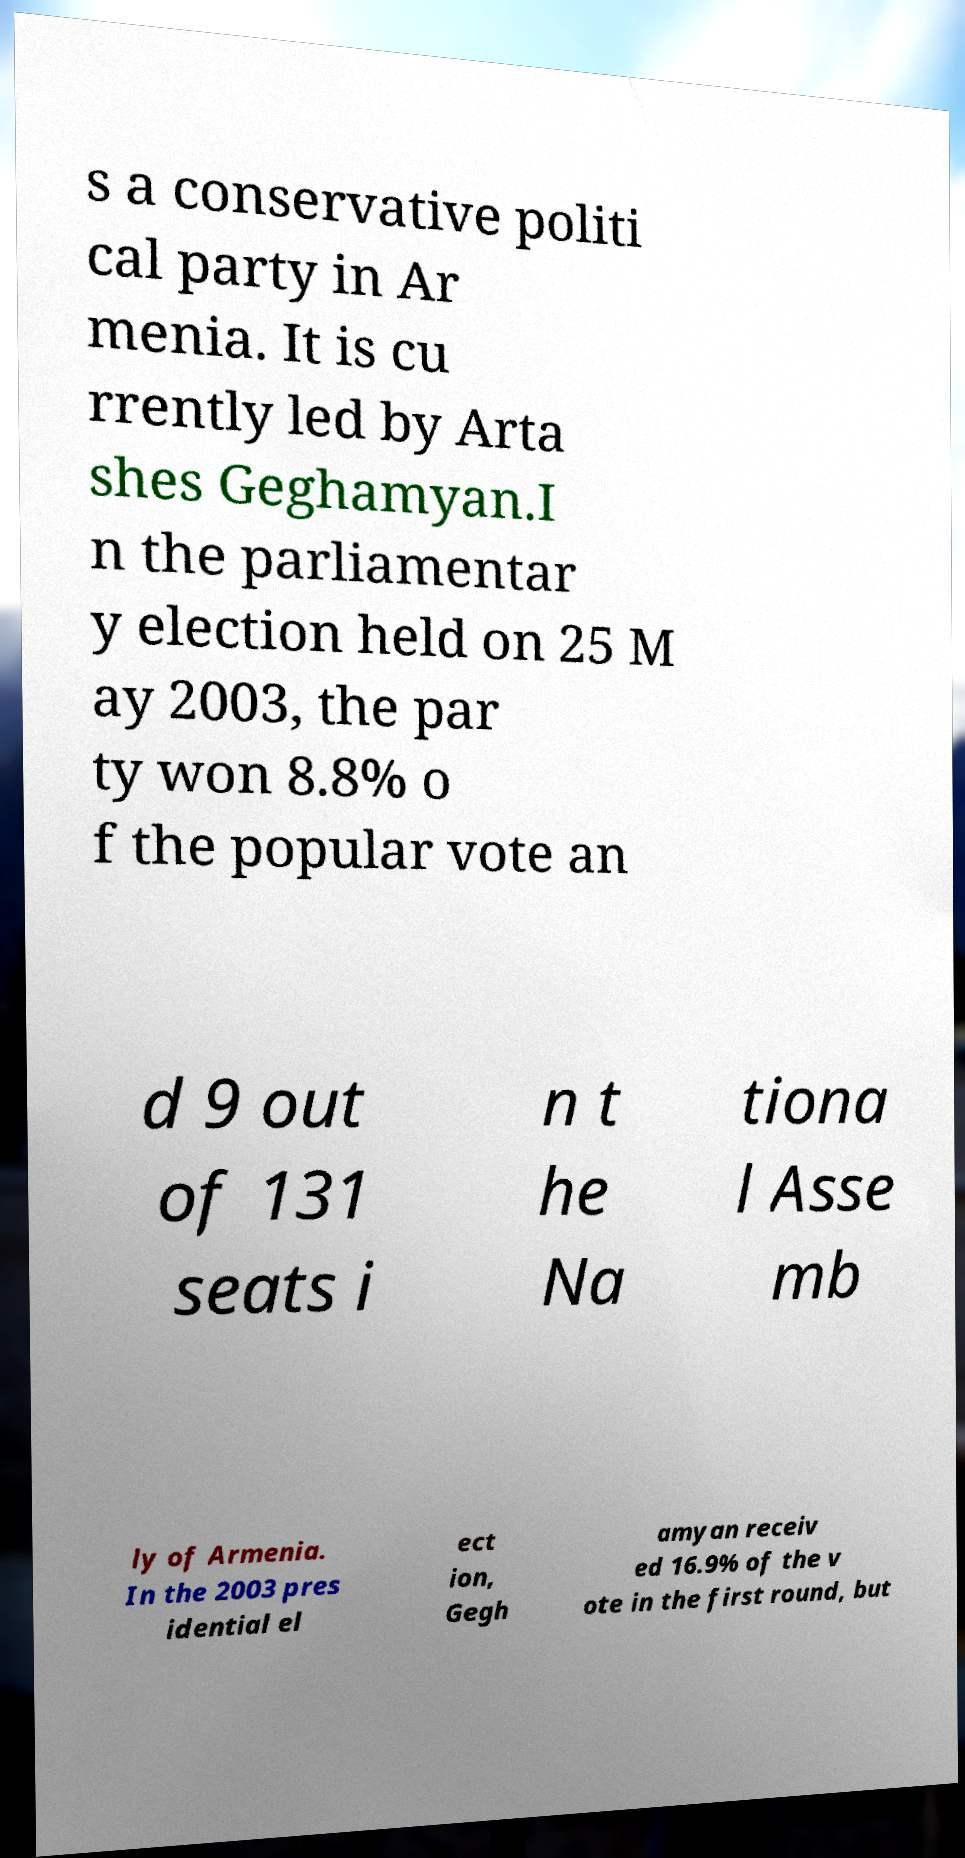There's text embedded in this image that I need extracted. Can you transcribe it verbatim? s a conservative politi cal party in Ar menia. It is cu rrently led by Arta shes Geghamyan.I n the parliamentar y election held on 25 M ay 2003, the par ty won 8.8% o f the popular vote an d 9 out of 131 seats i n t he Na tiona l Asse mb ly of Armenia. In the 2003 pres idential el ect ion, Gegh amyan receiv ed 16.9% of the v ote in the first round, but 